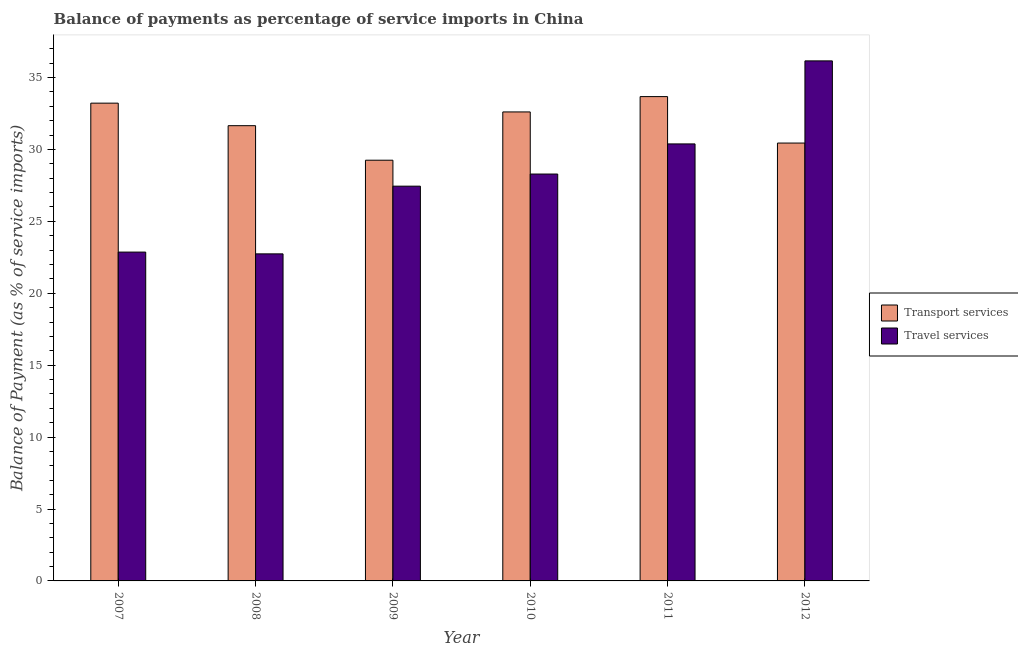How many different coloured bars are there?
Your response must be concise. 2. How many groups of bars are there?
Make the answer very short. 6. Are the number of bars per tick equal to the number of legend labels?
Give a very brief answer. Yes. How many bars are there on the 1st tick from the left?
Give a very brief answer. 2. What is the label of the 2nd group of bars from the left?
Your response must be concise. 2008. In how many cases, is the number of bars for a given year not equal to the number of legend labels?
Give a very brief answer. 0. What is the balance of payments of travel services in 2012?
Offer a terse response. 36.16. Across all years, what is the maximum balance of payments of travel services?
Your answer should be compact. 36.16. Across all years, what is the minimum balance of payments of transport services?
Give a very brief answer. 29.25. In which year was the balance of payments of transport services maximum?
Keep it short and to the point. 2011. In which year was the balance of payments of transport services minimum?
Ensure brevity in your answer.  2009. What is the total balance of payments of transport services in the graph?
Provide a succinct answer. 190.83. What is the difference between the balance of payments of transport services in 2008 and that in 2012?
Provide a short and direct response. 1.21. What is the difference between the balance of payments of transport services in 2008 and the balance of payments of travel services in 2010?
Keep it short and to the point. -0.96. What is the average balance of payments of travel services per year?
Keep it short and to the point. 27.98. In how many years, is the balance of payments of transport services greater than 5 %?
Ensure brevity in your answer.  6. What is the ratio of the balance of payments of transport services in 2007 to that in 2008?
Keep it short and to the point. 1.05. What is the difference between the highest and the second highest balance of payments of transport services?
Offer a terse response. 0.46. What is the difference between the highest and the lowest balance of payments of transport services?
Your response must be concise. 4.42. What does the 2nd bar from the left in 2007 represents?
Provide a short and direct response. Travel services. What does the 2nd bar from the right in 2007 represents?
Offer a very short reply. Transport services. Are all the bars in the graph horizontal?
Your response must be concise. No. How many years are there in the graph?
Your answer should be very brief. 6. Are the values on the major ticks of Y-axis written in scientific E-notation?
Ensure brevity in your answer.  No. Does the graph contain any zero values?
Make the answer very short. No. Where does the legend appear in the graph?
Your answer should be compact. Center right. How many legend labels are there?
Your response must be concise. 2. What is the title of the graph?
Provide a short and direct response. Balance of payments as percentage of service imports in China. Does "Age 15+" appear as one of the legend labels in the graph?
Offer a very short reply. No. What is the label or title of the X-axis?
Your answer should be compact. Year. What is the label or title of the Y-axis?
Your answer should be very brief. Balance of Payment (as % of service imports). What is the Balance of Payment (as % of service imports) in Transport services in 2007?
Provide a short and direct response. 33.22. What is the Balance of Payment (as % of service imports) of Travel services in 2007?
Provide a short and direct response. 22.86. What is the Balance of Payment (as % of service imports) of Transport services in 2008?
Give a very brief answer. 31.65. What is the Balance of Payment (as % of service imports) in Travel services in 2008?
Offer a very short reply. 22.74. What is the Balance of Payment (as % of service imports) in Transport services in 2009?
Offer a very short reply. 29.25. What is the Balance of Payment (as % of service imports) of Travel services in 2009?
Provide a succinct answer. 27.45. What is the Balance of Payment (as % of service imports) in Transport services in 2010?
Offer a terse response. 32.61. What is the Balance of Payment (as % of service imports) in Travel services in 2010?
Your response must be concise. 28.29. What is the Balance of Payment (as % of service imports) of Transport services in 2011?
Keep it short and to the point. 33.67. What is the Balance of Payment (as % of service imports) of Travel services in 2011?
Your response must be concise. 30.38. What is the Balance of Payment (as % of service imports) of Transport services in 2012?
Offer a terse response. 30.44. What is the Balance of Payment (as % of service imports) of Travel services in 2012?
Provide a short and direct response. 36.16. Across all years, what is the maximum Balance of Payment (as % of service imports) of Transport services?
Your answer should be compact. 33.67. Across all years, what is the maximum Balance of Payment (as % of service imports) in Travel services?
Keep it short and to the point. 36.16. Across all years, what is the minimum Balance of Payment (as % of service imports) in Transport services?
Offer a very short reply. 29.25. Across all years, what is the minimum Balance of Payment (as % of service imports) in Travel services?
Ensure brevity in your answer.  22.74. What is the total Balance of Payment (as % of service imports) in Transport services in the graph?
Make the answer very short. 190.83. What is the total Balance of Payment (as % of service imports) of Travel services in the graph?
Make the answer very short. 167.87. What is the difference between the Balance of Payment (as % of service imports) in Transport services in 2007 and that in 2008?
Offer a very short reply. 1.57. What is the difference between the Balance of Payment (as % of service imports) of Travel services in 2007 and that in 2008?
Offer a very short reply. 0.12. What is the difference between the Balance of Payment (as % of service imports) in Transport services in 2007 and that in 2009?
Provide a succinct answer. 3.97. What is the difference between the Balance of Payment (as % of service imports) of Travel services in 2007 and that in 2009?
Provide a succinct answer. -4.58. What is the difference between the Balance of Payment (as % of service imports) in Transport services in 2007 and that in 2010?
Offer a terse response. 0.61. What is the difference between the Balance of Payment (as % of service imports) of Travel services in 2007 and that in 2010?
Offer a terse response. -5.43. What is the difference between the Balance of Payment (as % of service imports) in Transport services in 2007 and that in 2011?
Your answer should be compact. -0.46. What is the difference between the Balance of Payment (as % of service imports) of Travel services in 2007 and that in 2011?
Your response must be concise. -7.52. What is the difference between the Balance of Payment (as % of service imports) of Transport services in 2007 and that in 2012?
Your response must be concise. 2.77. What is the difference between the Balance of Payment (as % of service imports) of Travel services in 2007 and that in 2012?
Ensure brevity in your answer.  -13.29. What is the difference between the Balance of Payment (as % of service imports) of Transport services in 2008 and that in 2009?
Ensure brevity in your answer.  2.4. What is the difference between the Balance of Payment (as % of service imports) of Travel services in 2008 and that in 2009?
Offer a very short reply. -4.71. What is the difference between the Balance of Payment (as % of service imports) of Transport services in 2008 and that in 2010?
Provide a short and direct response. -0.96. What is the difference between the Balance of Payment (as % of service imports) of Travel services in 2008 and that in 2010?
Your answer should be compact. -5.55. What is the difference between the Balance of Payment (as % of service imports) in Transport services in 2008 and that in 2011?
Ensure brevity in your answer.  -2.02. What is the difference between the Balance of Payment (as % of service imports) of Travel services in 2008 and that in 2011?
Your answer should be compact. -7.64. What is the difference between the Balance of Payment (as % of service imports) in Transport services in 2008 and that in 2012?
Offer a very short reply. 1.21. What is the difference between the Balance of Payment (as % of service imports) of Travel services in 2008 and that in 2012?
Give a very brief answer. -13.42. What is the difference between the Balance of Payment (as % of service imports) in Transport services in 2009 and that in 2010?
Provide a succinct answer. -3.36. What is the difference between the Balance of Payment (as % of service imports) in Travel services in 2009 and that in 2010?
Offer a terse response. -0.84. What is the difference between the Balance of Payment (as % of service imports) of Transport services in 2009 and that in 2011?
Provide a short and direct response. -4.42. What is the difference between the Balance of Payment (as % of service imports) in Travel services in 2009 and that in 2011?
Your answer should be very brief. -2.94. What is the difference between the Balance of Payment (as % of service imports) of Transport services in 2009 and that in 2012?
Your answer should be compact. -1.19. What is the difference between the Balance of Payment (as % of service imports) in Travel services in 2009 and that in 2012?
Make the answer very short. -8.71. What is the difference between the Balance of Payment (as % of service imports) of Transport services in 2010 and that in 2011?
Give a very brief answer. -1.07. What is the difference between the Balance of Payment (as % of service imports) of Travel services in 2010 and that in 2011?
Your response must be concise. -2.09. What is the difference between the Balance of Payment (as % of service imports) in Transport services in 2010 and that in 2012?
Offer a very short reply. 2.16. What is the difference between the Balance of Payment (as % of service imports) of Travel services in 2010 and that in 2012?
Make the answer very short. -7.87. What is the difference between the Balance of Payment (as % of service imports) in Transport services in 2011 and that in 2012?
Provide a succinct answer. 3.23. What is the difference between the Balance of Payment (as % of service imports) in Travel services in 2011 and that in 2012?
Keep it short and to the point. -5.77. What is the difference between the Balance of Payment (as % of service imports) in Transport services in 2007 and the Balance of Payment (as % of service imports) in Travel services in 2008?
Give a very brief answer. 10.48. What is the difference between the Balance of Payment (as % of service imports) of Transport services in 2007 and the Balance of Payment (as % of service imports) of Travel services in 2009?
Ensure brevity in your answer.  5.77. What is the difference between the Balance of Payment (as % of service imports) of Transport services in 2007 and the Balance of Payment (as % of service imports) of Travel services in 2010?
Keep it short and to the point. 4.93. What is the difference between the Balance of Payment (as % of service imports) in Transport services in 2007 and the Balance of Payment (as % of service imports) in Travel services in 2011?
Your answer should be compact. 2.83. What is the difference between the Balance of Payment (as % of service imports) of Transport services in 2007 and the Balance of Payment (as % of service imports) of Travel services in 2012?
Your answer should be compact. -2.94. What is the difference between the Balance of Payment (as % of service imports) in Transport services in 2008 and the Balance of Payment (as % of service imports) in Travel services in 2009?
Offer a very short reply. 4.2. What is the difference between the Balance of Payment (as % of service imports) of Transport services in 2008 and the Balance of Payment (as % of service imports) of Travel services in 2010?
Keep it short and to the point. 3.36. What is the difference between the Balance of Payment (as % of service imports) in Transport services in 2008 and the Balance of Payment (as % of service imports) in Travel services in 2011?
Ensure brevity in your answer.  1.27. What is the difference between the Balance of Payment (as % of service imports) in Transport services in 2008 and the Balance of Payment (as % of service imports) in Travel services in 2012?
Offer a very short reply. -4.51. What is the difference between the Balance of Payment (as % of service imports) in Transport services in 2009 and the Balance of Payment (as % of service imports) in Travel services in 2011?
Give a very brief answer. -1.13. What is the difference between the Balance of Payment (as % of service imports) in Transport services in 2009 and the Balance of Payment (as % of service imports) in Travel services in 2012?
Give a very brief answer. -6.91. What is the difference between the Balance of Payment (as % of service imports) in Transport services in 2010 and the Balance of Payment (as % of service imports) in Travel services in 2011?
Give a very brief answer. 2.22. What is the difference between the Balance of Payment (as % of service imports) in Transport services in 2010 and the Balance of Payment (as % of service imports) in Travel services in 2012?
Provide a succinct answer. -3.55. What is the difference between the Balance of Payment (as % of service imports) in Transport services in 2011 and the Balance of Payment (as % of service imports) in Travel services in 2012?
Provide a succinct answer. -2.48. What is the average Balance of Payment (as % of service imports) in Transport services per year?
Your response must be concise. 31.81. What is the average Balance of Payment (as % of service imports) of Travel services per year?
Your response must be concise. 27.98. In the year 2007, what is the difference between the Balance of Payment (as % of service imports) in Transport services and Balance of Payment (as % of service imports) in Travel services?
Ensure brevity in your answer.  10.35. In the year 2008, what is the difference between the Balance of Payment (as % of service imports) in Transport services and Balance of Payment (as % of service imports) in Travel services?
Provide a short and direct response. 8.91. In the year 2009, what is the difference between the Balance of Payment (as % of service imports) of Transport services and Balance of Payment (as % of service imports) of Travel services?
Provide a short and direct response. 1.8. In the year 2010, what is the difference between the Balance of Payment (as % of service imports) in Transport services and Balance of Payment (as % of service imports) in Travel services?
Keep it short and to the point. 4.32. In the year 2011, what is the difference between the Balance of Payment (as % of service imports) of Transport services and Balance of Payment (as % of service imports) of Travel services?
Provide a short and direct response. 3.29. In the year 2012, what is the difference between the Balance of Payment (as % of service imports) of Transport services and Balance of Payment (as % of service imports) of Travel services?
Give a very brief answer. -5.71. What is the ratio of the Balance of Payment (as % of service imports) in Transport services in 2007 to that in 2008?
Provide a short and direct response. 1.05. What is the ratio of the Balance of Payment (as % of service imports) of Travel services in 2007 to that in 2008?
Keep it short and to the point. 1.01. What is the ratio of the Balance of Payment (as % of service imports) in Transport services in 2007 to that in 2009?
Your answer should be very brief. 1.14. What is the ratio of the Balance of Payment (as % of service imports) in Travel services in 2007 to that in 2009?
Provide a short and direct response. 0.83. What is the ratio of the Balance of Payment (as % of service imports) of Transport services in 2007 to that in 2010?
Provide a short and direct response. 1.02. What is the ratio of the Balance of Payment (as % of service imports) of Travel services in 2007 to that in 2010?
Give a very brief answer. 0.81. What is the ratio of the Balance of Payment (as % of service imports) of Transport services in 2007 to that in 2011?
Give a very brief answer. 0.99. What is the ratio of the Balance of Payment (as % of service imports) in Travel services in 2007 to that in 2011?
Your answer should be compact. 0.75. What is the ratio of the Balance of Payment (as % of service imports) of Transport services in 2007 to that in 2012?
Offer a terse response. 1.09. What is the ratio of the Balance of Payment (as % of service imports) in Travel services in 2007 to that in 2012?
Your answer should be compact. 0.63. What is the ratio of the Balance of Payment (as % of service imports) in Transport services in 2008 to that in 2009?
Your response must be concise. 1.08. What is the ratio of the Balance of Payment (as % of service imports) of Travel services in 2008 to that in 2009?
Your answer should be very brief. 0.83. What is the ratio of the Balance of Payment (as % of service imports) in Transport services in 2008 to that in 2010?
Your response must be concise. 0.97. What is the ratio of the Balance of Payment (as % of service imports) of Travel services in 2008 to that in 2010?
Provide a short and direct response. 0.8. What is the ratio of the Balance of Payment (as % of service imports) in Transport services in 2008 to that in 2011?
Offer a terse response. 0.94. What is the ratio of the Balance of Payment (as % of service imports) in Travel services in 2008 to that in 2011?
Your answer should be compact. 0.75. What is the ratio of the Balance of Payment (as % of service imports) in Transport services in 2008 to that in 2012?
Offer a terse response. 1.04. What is the ratio of the Balance of Payment (as % of service imports) of Travel services in 2008 to that in 2012?
Give a very brief answer. 0.63. What is the ratio of the Balance of Payment (as % of service imports) in Transport services in 2009 to that in 2010?
Provide a short and direct response. 0.9. What is the ratio of the Balance of Payment (as % of service imports) of Travel services in 2009 to that in 2010?
Provide a succinct answer. 0.97. What is the ratio of the Balance of Payment (as % of service imports) in Transport services in 2009 to that in 2011?
Ensure brevity in your answer.  0.87. What is the ratio of the Balance of Payment (as % of service imports) of Travel services in 2009 to that in 2011?
Offer a very short reply. 0.9. What is the ratio of the Balance of Payment (as % of service imports) in Transport services in 2009 to that in 2012?
Your response must be concise. 0.96. What is the ratio of the Balance of Payment (as % of service imports) of Travel services in 2009 to that in 2012?
Give a very brief answer. 0.76. What is the ratio of the Balance of Payment (as % of service imports) of Transport services in 2010 to that in 2011?
Ensure brevity in your answer.  0.97. What is the ratio of the Balance of Payment (as % of service imports) in Travel services in 2010 to that in 2011?
Keep it short and to the point. 0.93. What is the ratio of the Balance of Payment (as % of service imports) in Transport services in 2010 to that in 2012?
Ensure brevity in your answer.  1.07. What is the ratio of the Balance of Payment (as % of service imports) in Travel services in 2010 to that in 2012?
Ensure brevity in your answer.  0.78. What is the ratio of the Balance of Payment (as % of service imports) in Transport services in 2011 to that in 2012?
Ensure brevity in your answer.  1.11. What is the ratio of the Balance of Payment (as % of service imports) of Travel services in 2011 to that in 2012?
Offer a very short reply. 0.84. What is the difference between the highest and the second highest Balance of Payment (as % of service imports) in Transport services?
Ensure brevity in your answer.  0.46. What is the difference between the highest and the second highest Balance of Payment (as % of service imports) of Travel services?
Make the answer very short. 5.77. What is the difference between the highest and the lowest Balance of Payment (as % of service imports) in Transport services?
Offer a very short reply. 4.42. What is the difference between the highest and the lowest Balance of Payment (as % of service imports) in Travel services?
Your response must be concise. 13.42. 